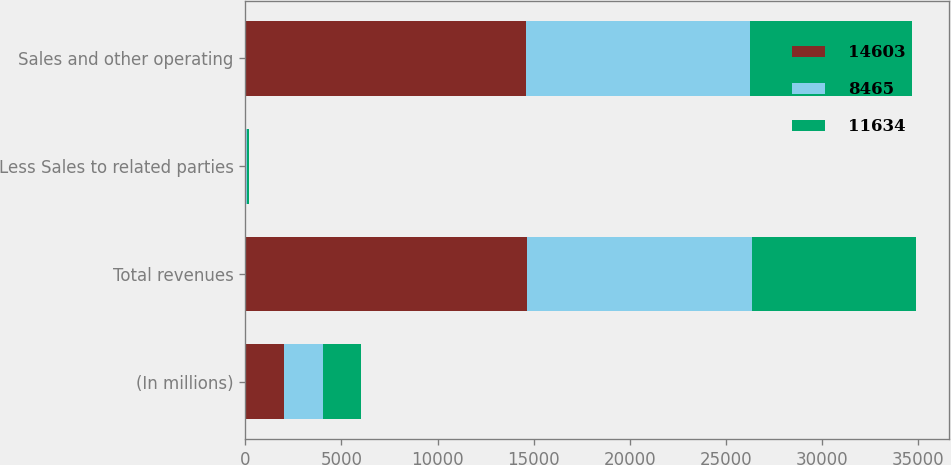Convert chart. <chart><loc_0><loc_0><loc_500><loc_500><stacked_bar_chart><ecel><fcel>(In millions)<fcel>Total revenues<fcel>Less Sales to related parties<fcel>Sales and other operating<nl><fcel>14603<fcel>2011<fcel>14663<fcel>60<fcel>14603<nl><fcel>8465<fcel>2010<fcel>11690<fcel>56<fcel>11634<nl><fcel>11634<fcel>2009<fcel>8524<fcel>59<fcel>8465<nl></chart> 